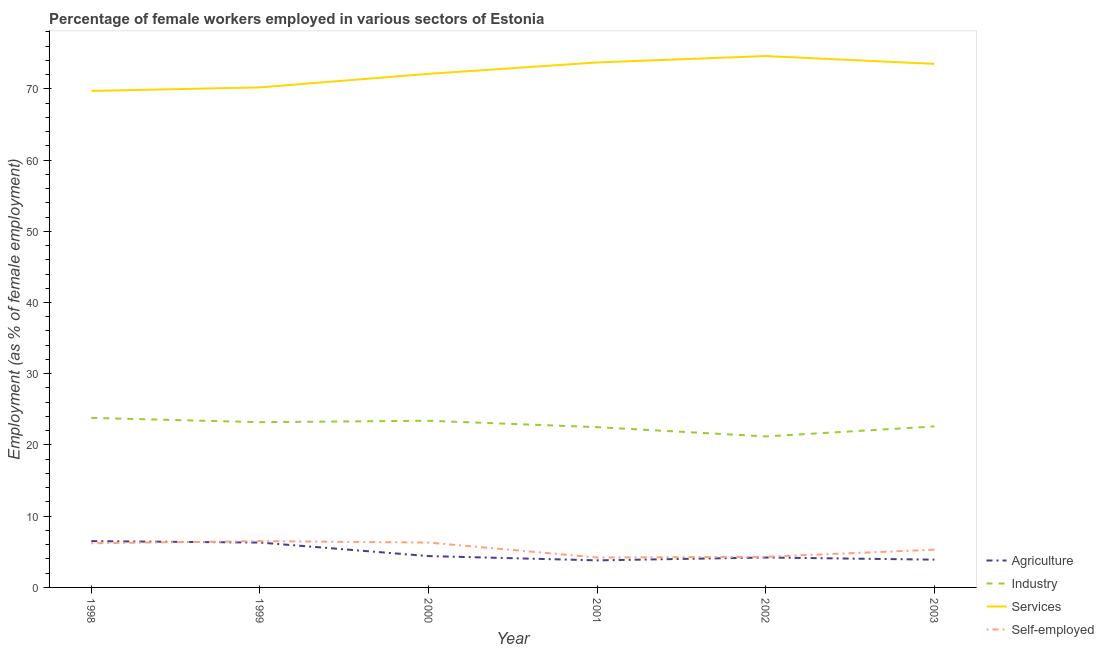What is the percentage of female workers in agriculture in 2003?
Your response must be concise. 3.9. Across all years, what is the maximum percentage of female workers in industry?
Offer a terse response. 23.8. Across all years, what is the minimum percentage of self employed female workers?
Give a very brief answer. 4.2. In which year was the percentage of female workers in industry minimum?
Provide a succinct answer. 2002. What is the total percentage of female workers in services in the graph?
Keep it short and to the point. 433.8. What is the difference between the percentage of female workers in services in 2000 and that in 2003?
Keep it short and to the point. -1.4. What is the difference between the percentage of female workers in industry in 2001 and the percentage of female workers in services in 1999?
Your answer should be compact. -47.7. What is the average percentage of self employed female workers per year?
Offer a terse response. 5.47. In the year 2003, what is the difference between the percentage of female workers in services and percentage of female workers in agriculture?
Make the answer very short. 69.6. What is the ratio of the percentage of female workers in industry in 1998 to that in 1999?
Your response must be concise. 1.03. Is the percentage of female workers in services in 1999 less than that in 2001?
Offer a terse response. Yes. Is the difference between the percentage of female workers in agriculture in 1998 and 2002 greater than the difference between the percentage of female workers in industry in 1998 and 2002?
Provide a succinct answer. No. What is the difference between the highest and the second highest percentage of female workers in services?
Give a very brief answer. 0.9. What is the difference between the highest and the lowest percentage of female workers in industry?
Your answer should be very brief. 2.6. In how many years, is the percentage of self employed female workers greater than the average percentage of self employed female workers taken over all years?
Give a very brief answer. 3. Is the sum of the percentage of female workers in industry in 2000 and 2003 greater than the maximum percentage of female workers in agriculture across all years?
Ensure brevity in your answer.  Yes. Is it the case that in every year, the sum of the percentage of self employed female workers and percentage of female workers in services is greater than the sum of percentage of female workers in industry and percentage of female workers in agriculture?
Provide a short and direct response. Yes. Is the percentage of female workers in industry strictly greater than the percentage of self employed female workers over the years?
Offer a very short reply. Yes. How many years are there in the graph?
Provide a succinct answer. 6. What is the difference between two consecutive major ticks on the Y-axis?
Your answer should be very brief. 10. Does the graph contain any zero values?
Offer a terse response. No. Does the graph contain grids?
Offer a terse response. No. Where does the legend appear in the graph?
Offer a terse response. Bottom right. What is the title of the graph?
Offer a very short reply. Percentage of female workers employed in various sectors of Estonia. What is the label or title of the Y-axis?
Your response must be concise. Employment (as % of female employment). What is the Employment (as % of female employment) in Industry in 1998?
Give a very brief answer. 23.8. What is the Employment (as % of female employment) of Services in 1998?
Provide a short and direct response. 69.7. What is the Employment (as % of female employment) in Self-employed in 1998?
Your answer should be compact. 6.2. What is the Employment (as % of female employment) of Agriculture in 1999?
Keep it short and to the point. 6.3. What is the Employment (as % of female employment) of Industry in 1999?
Give a very brief answer. 23.2. What is the Employment (as % of female employment) in Services in 1999?
Your answer should be very brief. 70.2. What is the Employment (as % of female employment) in Self-employed in 1999?
Keep it short and to the point. 6.5. What is the Employment (as % of female employment) of Agriculture in 2000?
Offer a very short reply. 4.4. What is the Employment (as % of female employment) in Industry in 2000?
Your response must be concise. 23.4. What is the Employment (as % of female employment) of Services in 2000?
Provide a succinct answer. 72.1. What is the Employment (as % of female employment) of Self-employed in 2000?
Keep it short and to the point. 6.3. What is the Employment (as % of female employment) in Agriculture in 2001?
Ensure brevity in your answer.  3.8. What is the Employment (as % of female employment) of Services in 2001?
Provide a short and direct response. 73.7. What is the Employment (as % of female employment) in Self-employed in 2001?
Provide a short and direct response. 4.2. What is the Employment (as % of female employment) in Agriculture in 2002?
Your answer should be compact. 4.2. What is the Employment (as % of female employment) in Industry in 2002?
Offer a very short reply. 21.2. What is the Employment (as % of female employment) in Services in 2002?
Give a very brief answer. 74.6. What is the Employment (as % of female employment) in Self-employed in 2002?
Your response must be concise. 4.3. What is the Employment (as % of female employment) of Agriculture in 2003?
Give a very brief answer. 3.9. What is the Employment (as % of female employment) in Industry in 2003?
Give a very brief answer. 22.6. What is the Employment (as % of female employment) of Services in 2003?
Provide a short and direct response. 73.5. What is the Employment (as % of female employment) in Self-employed in 2003?
Offer a very short reply. 5.3. Across all years, what is the maximum Employment (as % of female employment) of Agriculture?
Your response must be concise. 6.5. Across all years, what is the maximum Employment (as % of female employment) in Industry?
Your answer should be very brief. 23.8. Across all years, what is the maximum Employment (as % of female employment) in Services?
Ensure brevity in your answer.  74.6. Across all years, what is the minimum Employment (as % of female employment) of Agriculture?
Make the answer very short. 3.8. Across all years, what is the minimum Employment (as % of female employment) of Industry?
Provide a succinct answer. 21.2. Across all years, what is the minimum Employment (as % of female employment) of Services?
Your response must be concise. 69.7. Across all years, what is the minimum Employment (as % of female employment) in Self-employed?
Make the answer very short. 4.2. What is the total Employment (as % of female employment) in Agriculture in the graph?
Give a very brief answer. 29.1. What is the total Employment (as % of female employment) in Industry in the graph?
Offer a terse response. 136.7. What is the total Employment (as % of female employment) in Services in the graph?
Provide a succinct answer. 433.8. What is the total Employment (as % of female employment) of Self-employed in the graph?
Your answer should be compact. 32.8. What is the difference between the Employment (as % of female employment) of Agriculture in 1998 and that in 1999?
Make the answer very short. 0.2. What is the difference between the Employment (as % of female employment) in Industry in 1998 and that in 1999?
Your answer should be very brief. 0.6. What is the difference between the Employment (as % of female employment) of Services in 1998 and that in 1999?
Give a very brief answer. -0.5. What is the difference between the Employment (as % of female employment) in Industry in 1998 and that in 2000?
Offer a terse response. 0.4. What is the difference between the Employment (as % of female employment) of Self-employed in 1998 and that in 2000?
Provide a succinct answer. -0.1. What is the difference between the Employment (as % of female employment) of Agriculture in 1998 and that in 2002?
Offer a very short reply. 2.3. What is the difference between the Employment (as % of female employment) of Industry in 1998 and that in 2002?
Your answer should be compact. 2.6. What is the difference between the Employment (as % of female employment) of Self-employed in 1998 and that in 2002?
Ensure brevity in your answer.  1.9. What is the difference between the Employment (as % of female employment) in Industry in 1998 and that in 2003?
Offer a very short reply. 1.2. What is the difference between the Employment (as % of female employment) of Self-employed in 1998 and that in 2003?
Your answer should be compact. 0.9. What is the difference between the Employment (as % of female employment) of Agriculture in 1999 and that in 2001?
Offer a very short reply. 2.5. What is the difference between the Employment (as % of female employment) in Services in 1999 and that in 2001?
Offer a terse response. -3.5. What is the difference between the Employment (as % of female employment) of Agriculture in 1999 and that in 2002?
Offer a terse response. 2.1. What is the difference between the Employment (as % of female employment) in Services in 1999 and that in 2002?
Your answer should be very brief. -4.4. What is the difference between the Employment (as % of female employment) in Agriculture in 1999 and that in 2003?
Offer a terse response. 2.4. What is the difference between the Employment (as % of female employment) in Services in 1999 and that in 2003?
Keep it short and to the point. -3.3. What is the difference between the Employment (as % of female employment) of Self-employed in 1999 and that in 2003?
Give a very brief answer. 1.2. What is the difference between the Employment (as % of female employment) in Industry in 2000 and that in 2002?
Offer a terse response. 2.2. What is the difference between the Employment (as % of female employment) in Services in 2000 and that in 2002?
Your response must be concise. -2.5. What is the difference between the Employment (as % of female employment) of Agriculture in 2000 and that in 2003?
Your answer should be compact. 0.5. What is the difference between the Employment (as % of female employment) of Industry in 2000 and that in 2003?
Ensure brevity in your answer.  0.8. What is the difference between the Employment (as % of female employment) in Services in 2000 and that in 2003?
Offer a very short reply. -1.4. What is the difference between the Employment (as % of female employment) in Self-employed in 2000 and that in 2003?
Your answer should be very brief. 1. What is the difference between the Employment (as % of female employment) in Self-employed in 2001 and that in 2002?
Provide a short and direct response. -0.1. What is the difference between the Employment (as % of female employment) of Agriculture in 2001 and that in 2003?
Your answer should be compact. -0.1. What is the difference between the Employment (as % of female employment) in Services in 2001 and that in 2003?
Give a very brief answer. 0.2. What is the difference between the Employment (as % of female employment) in Self-employed in 2001 and that in 2003?
Offer a terse response. -1.1. What is the difference between the Employment (as % of female employment) of Agriculture in 2002 and that in 2003?
Give a very brief answer. 0.3. What is the difference between the Employment (as % of female employment) of Industry in 2002 and that in 2003?
Offer a very short reply. -1.4. What is the difference between the Employment (as % of female employment) in Services in 2002 and that in 2003?
Keep it short and to the point. 1.1. What is the difference between the Employment (as % of female employment) of Self-employed in 2002 and that in 2003?
Give a very brief answer. -1. What is the difference between the Employment (as % of female employment) in Agriculture in 1998 and the Employment (as % of female employment) in Industry in 1999?
Keep it short and to the point. -16.7. What is the difference between the Employment (as % of female employment) in Agriculture in 1998 and the Employment (as % of female employment) in Services in 1999?
Your answer should be compact. -63.7. What is the difference between the Employment (as % of female employment) of Industry in 1998 and the Employment (as % of female employment) of Services in 1999?
Offer a terse response. -46.4. What is the difference between the Employment (as % of female employment) of Industry in 1998 and the Employment (as % of female employment) of Self-employed in 1999?
Provide a short and direct response. 17.3. What is the difference between the Employment (as % of female employment) of Services in 1998 and the Employment (as % of female employment) of Self-employed in 1999?
Keep it short and to the point. 63.2. What is the difference between the Employment (as % of female employment) of Agriculture in 1998 and the Employment (as % of female employment) of Industry in 2000?
Provide a succinct answer. -16.9. What is the difference between the Employment (as % of female employment) in Agriculture in 1998 and the Employment (as % of female employment) in Services in 2000?
Ensure brevity in your answer.  -65.6. What is the difference between the Employment (as % of female employment) of Agriculture in 1998 and the Employment (as % of female employment) of Self-employed in 2000?
Your response must be concise. 0.2. What is the difference between the Employment (as % of female employment) in Industry in 1998 and the Employment (as % of female employment) in Services in 2000?
Keep it short and to the point. -48.3. What is the difference between the Employment (as % of female employment) of Industry in 1998 and the Employment (as % of female employment) of Self-employed in 2000?
Give a very brief answer. 17.5. What is the difference between the Employment (as % of female employment) of Services in 1998 and the Employment (as % of female employment) of Self-employed in 2000?
Provide a short and direct response. 63.4. What is the difference between the Employment (as % of female employment) in Agriculture in 1998 and the Employment (as % of female employment) in Industry in 2001?
Make the answer very short. -16. What is the difference between the Employment (as % of female employment) in Agriculture in 1998 and the Employment (as % of female employment) in Services in 2001?
Provide a short and direct response. -67.2. What is the difference between the Employment (as % of female employment) in Industry in 1998 and the Employment (as % of female employment) in Services in 2001?
Offer a very short reply. -49.9. What is the difference between the Employment (as % of female employment) of Industry in 1998 and the Employment (as % of female employment) of Self-employed in 2001?
Offer a very short reply. 19.6. What is the difference between the Employment (as % of female employment) of Services in 1998 and the Employment (as % of female employment) of Self-employed in 2001?
Make the answer very short. 65.5. What is the difference between the Employment (as % of female employment) of Agriculture in 1998 and the Employment (as % of female employment) of Industry in 2002?
Offer a terse response. -14.7. What is the difference between the Employment (as % of female employment) of Agriculture in 1998 and the Employment (as % of female employment) of Services in 2002?
Provide a succinct answer. -68.1. What is the difference between the Employment (as % of female employment) in Agriculture in 1998 and the Employment (as % of female employment) in Self-employed in 2002?
Your answer should be compact. 2.2. What is the difference between the Employment (as % of female employment) of Industry in 1998 and the Employment (as % of female employment) of Services in 2002?
Offer a very short reply. -50.8. What is the difference between the Employment (as % of female employment) in Services in 1998 and the Employment (as % of female employment) in Self-employed in 2002?
Ensure brevity in your answer.  65.4. What is the difference between the Employment (as % of female employment) in Agriculture in 1998 and the Employment (as % of female employment) in Industry in 2003?
Your answer should be very brief. -16.1. What is the difference between the Employment (as % of female employment) of Agriculture in 1998 and the Employment (as % of female employment) of Services in 2003?
Give a very brief answer. -67. What is the difference between the Employment (as % of female employment) in Industry in 1998 and the Employment (as % of female employment) in Services in 2003?
Your answer should be very brief. -49.7. What is the difference between the Employment (as % of female employment) in Services in 1998 and the Employment (as % of female employment) in Self-employed in 2003?
Make the answer very short. 64.4. What is the difference between the Employment (as % of female employment) of Agriculture in 1999 and the Employment (as % of female employment) of Industry in 2000?
Give a very brief answer. -17.1. What is the difference between the Employment (as % of female employment) in Agriculture in 1999 and the Employment (as % of female employment) in Services in 2000?
Keep it short and to the point. -65.8. What is the difference between the Employment (as % of female employment) of Industry in 1999 and the Employment (as % of female employment) of Services in 2000?
Ensure brevity in your answer.  -48.9. What is the difference between the Employment (as % of female employment) in Industry in 1999 and the Employment (as % of female employment) in Self-employed in 2000?
Offer a terse response. 16.9. What is the difference between the Employment (as % of female employment) of Services in 1999 and the Employment (as % of female employment) of Self-employed in 2000?
Ensure brevity in your answer.  63.9. What is the difference between the Employment (as % of female employment) in Agriculture in 1999 and the Employment (as % of female employment) in Industry in 2001?
Your response must be concise. -16.2. What is the difference between the Employment (as % of female employment) of Agriculture in 1999 and the Employment (as % of female employment) of Services in 2001?
Your answer should be compact. -67.4. What is the difference between the Employment (as % of female employment) in Agriculture in 1999 and the Employment (as % of female employment) in Self-employed in 2001?
Your answer should be very brief. 2.1. What is the difference between the Employment (as % of female employment) in Industry in 1999 and the Employment (as % of female employment) in Services in 2001?
Your answer should be very brief. -50.5. What is the difference between the Employment (as % of female employment) of Industry in 1999 and the Employment (as % of female employment) of Self-employed in 2001?
Your response must be concise. 19. What is the difference between the Employment (as % of female employment) in Agriculture in 1999 and the Employment (as % of female employment) in Industry in 2002?
Offer a very short reply. -14.9. What is the difference between the Employment (as % of female employment) of Agriculture in 1999 and the Employment (as % of female employment) of Services in 2002?
Your response must be concise. -68.3. What is the difference between the Employment (as % of female employment) of Industry in 1999 and the Employment (as % of female employment) of Services in 2002?
Your answer should be compact. -51.4. What is the difference between the Employment (as % of female employment) of Industry in 1999 and the Employment (as % of female employment) of Self-employed in 2002?
Offer a very short reply. 18.9. What is the difference between the Employment (as % of female employment) in Services in 1999 and the Employment (as % of female employment) in Self-employed in 2002?
Provide a short and direct response. 65.9. What is the difference between the Employment (as % of female employment) of Agriculture in 1999 and the Employment (as % of female employment) of Industry in 2003?
Give a very brief answer. -16.3. What is the difference between the Employment (as % of female employment) of Agriculture in 1999 and the Employment (as % of female employment) of Services in 2003?
Keep it short and to the point. -67.2. What is the difference between the Employment (as % of female employment) in Agriculture in 1999 and the Employment (as % of female employment) in Self-employed in 2003?
Your response must be concise. 1. What is the difference between the Employment (as % of female employment) in Industry in 1999 and the Employment (as % of female employment) in Services in 2003?
Offer a terse response. -50.3. What is the difference between the Employment (as % of female employment) of Services in 1999 and the Employment (as % of female employment) of Self-employed in 2003?
Provide a short and direct response. 64.9. What is the difference between the Employment (as % of female employment) of Agriculture in 2000 and the Employment (as % of female employment) of Industry in 2001?
Provide a succinct answer. -18.1. What is the difference between the Employment (as % of female employment) in Agriculture in 2000 and the Employment (as % of female employment) in Services in 2001?
Provide a succinct answer. -69.3. What is the difference between the Employment (as % of female employment) in Industry in 2000 and the Employment (as % of female employment) in Services in 2001?
Provide a short and direct response. -50.3. What is the difference between the Employment (as % of female employment) of Services in 2000 and the Employment (as % of female employment) of Self-employed in 2001?
Keep it short and to the point. 67.9. What is the difference between the Employment (as % of female employment) in Agriculture in 2000 and the Employment (as % of female employment) in Industry in 2002?
Your answer should be compact. -16.8. What is the difference between the Employment (as % of female employment) in Agriculture in 2000 and the Employment (as % of female employment) in Services in 2002?
Make the answer very short. -70.2. What is the difference between the Employment (as % of female employment) in Industry in 2000 and the Employment (as % of female employment) in Services in 2002?
Keep it short and to the point. -51.2. What is the difference between the Employment (as % of female employment) of Industry in 2000 and the Employment (as % of female employment) of Self-employed in 2002?
Provide a short and direct response. 19.1. What is the difference between the Employment (as % of female employment) in Services in 2000 and the Employment (as % of female employment) in Self-employed in 2002?
Keep it short and to the point. 67.8. What is the difference between the Employment (as % of female employment) in Agriculture in 2000 and the Employment (as % of female employment) in Industry in 2003?
Offer a terse response. -18.2. What is the difference between the Employment (as % of female employment) of Agriculture in 2000 and the Employment (as % of female employment) of Services in 2003?
Offer a terse response. -69.1. What is the difference between the Employment (as % of female employment) of Agriculture in 2000 and the Employment (as % of female employment) of Self-employed in 2003?
Make the answer very short. -0.9. What is the difference between the Employment (as % of female employment) in Industry in 2000 and the Employment (as % of female employment) in Services in 2003?
Your response must be concise. -50.1. What is the difference between the Employment (as % of female employment) in Services in 2000 and the Employment (as % of female employment) in Self-employed in 2003?
Provide a short and direct response. 66.8. What is the difference between the Employment (as % of female employment) of Agriculture in 2001 and the Employment (as % of female employment) of Industry in 2002?
Your response must be concise. -17.4. What is the difference between the Employment (as % of female employment) of Agriculture in 2001 and the Employment (as % of female employment) of Services in 2002?
Provide a succinct answer. -70.8. What is the difference between the Employment (as % of female employment) of Industry in 2001 and the Employment (as % of female employment) of Services in 2002?
Ensure brevity in your answer.  -52.1. What is the difference between the Employment (as % of female employment) of Services in 2001 and the Employment (as % of female employment) of Self-employed in 2002?
Provide a succinct answer. 69.4. What is the difference between the Employment (as % of female employment) in Agriculture in 2001 and the Employment (as % of female employment) in Industry in 2003?
Make the answer very short. -18.8. What is the difference between the Employment (as % of female employment) of Agriculture in 2001 and the Employment (as % of female employment) of Services in 2003?
Your answer should be very brief. -69.7. What is the difference between the Employment (as % of female employment) of Industry in 2001 and the Employment (as % of female employment) of Services in 2003?
Provide a short and direct response. -51. What is the difference between the Employment (as % of female employment) in Services in 2001 and the Employment (as % of female employment) in Self-employed in 2003?
Ensure brevity in your answer.  68.4. What is the difference between the Employment (as % of female employment) of Agriculture in 2002 and the Employment (as % of female employment) of Industry in 2003?
Keep it short and to the point. -18.4. What is the difference between the Employment (as % of female employment) in Agriculture in 2002 and the Employment (as % of female employment) in Services in 2003?
Your answer should be compact. -69.3. What is the difference between the Employment (as % of female employment) in Industry in 2002 and the Employment (as % of female employment) in Services in 2003?
Your answer should be very brief. -52.3. What is the difference between the Employment (as % of female employment) in Industry in 2002 and the Employment (as % of female employment) in Self-employed in 2003?
Your answer should be compact. 15.9. What is the difference between the Employment (as % of female employment) in Services in 2002 and the Employment (as % of female employment) in Self-employed in 2003?
Your response must be concise. 69.3. What is the average Employment (as % of female employment) in Agriculture per year?
Your response must be concise. 4.85. What is the average Employment (as % of female employment) in Industry per year?
Your response must be concise. 22.78. What is the average Employment (as % of female employment) in Services per year?
Ensure brevity in your answer.  72.3. What is the average Employment (as % of female employment) in Self-employed per year?
Provide a short and direct response. 5.47. In the year 1998, what is the difference between the Employment (as % of female employment) in Agriculture and Employment (as % of female employment) in Industry?
Provide a short and direct response. -17.3. In the year 1998, what is the difference between the Employment (as % of female employment) of Agriculture and Employment (as % of female employment) of Services?
Offer a very short reply. -63.2. In the year 1998, what is the difference between the Employment (as % of female employment) in Industry and Employment (as % of female employment) in Services?
Give a very brief answer. -45.9. In the year 1998, what is the difference between the Employment (as % of female employment) in Industry and Employment (as % of female employment) in Self-employed?
Give a very brief answer. 17.6. In the year 1998, what is the difference between the Employment (as % of female employment) of Services and Employment (as % of female employment) of Self-employed?
Offer a very short reply. 63.5. In the year 1999, what is the difference between the Employment (as % of female employment) in Agriculture and Employment (as % of female employment) in Industry?
Ensure brevity in your answer.  -16.9. In the year 1999, what is the difference between the Employment (as % of female employment) of Agriculture and Employment (as % of female employment) of Services?
Keep it short and to the point. -63.9. In the year 1999, what is the difference between the Employment (as % of female employment) in Industry and Employment (as % of female employment) in Services?
Your answer should be very brief. -47. In the year 1999, what is the difference between the Employment (as % of female employment) in Services and Employment (as % of female employment) in Self-employed?
Make the answer very short. 63.7. In the year 2000, what is the difference between the Employment (as % of female employment) in Agriculture and Employment (as % of female employment) in Services?
Your response must be concise. -67.7. In the year 2000, what is the difference between the Employment (as % of female employment) of Agriculture and Employment (as % of female employment) of Self-employed?
Your answer should be very brief. -1.9. In the year 2000, what is the difference between the Employment (as % of female employment) in Industry and Employment (as % of female employment) in Services?
Keep it short and to the point. -48.7. In the year 2000, what is the difference between the Employment (as % of female employment) in Industry and Employment (as % of female employment) in Self-employed?
Your answer should be compact. 17.1. In the year 2000, what is the difference between the Employment (as % of female employment) of Services and Employment (as % of female employment) of Self-employed?
Your response must be concise. 65.8. In the year 2001, what is the difference between the Employment (as % of female employment) in Agriculture and Employment (as % of female employment) in Industry?
Provide a succinct answer. -18.7. In the year 2001, what is the difference between the Employment (as % of female employment) in Agriculture and Employment (as % of female employment) in Services?
Give a very brief answer. -69.9. In the year 2001, what is the difference between the Employment (as % of female employment) of Industry and Employment (as % of female employment) of Services?
Make the answer very short. -51.2. In the year 2001, what is the difference between the Employment (as % of female employment) of Industry and Employment (as % of female employment) of Self-employed?
Keep it short and to the point. 18.3. In the year 2001, what is the difference between the Employment (as % of female employment) of Services and Employment (as % of female employment) of Self-employed?
Give a very brief answer. 69.5. In the year 2002, what is the difference between the Employment (as % of female employment) in Agriculture and Employment (as % of female employment) in Services?
Provide a short and direct response. -70.4. In the year 2002, what is the difference between the Employment (as % of female employment) in Industry and Employment (as % of female employment) in Services?
Offer a very short reply. -53.4. In the year 2002, what is the difference between the Employment (as % of female employment) in Industry and Employment (as % of female employment) in Self-employed?
Keep it short and to the point. 16.9. In the year 2002, what is the difference between the Employment (as % of female employment) of Services and Employment (as % of female employment) of Self-employed?
Your answer should be compact. 70.3. In the year 2003, what is the difference between the Employment (as % of female employment) of Agriculture and Employment (as % of female employment) of Industry?
Offer a terse response. -18.7. In the year 2003, what is the difference between the Employment (as % of female employment) in Agriculture and Employment (as % of female employment) in Services?
Provide a short and direct response. -69.6. In the year 2003, what is the difference between the Employment (as % of female employment) in Agriculture and Employment (as % of female employment) in Self-employed?
Provide a succinct answer. -1.4. In the year 2003, what is the difference between the Employment (as % of female employment) of Industry and Employment (as % of female employment) of Services?
Keep it short and to the point. -50.9. In the year 2003, what is the difference between the Employment (as % of female employment) in Industry and Employment (as % of female employment) in Self-employed?
Provide a succinct answer. 17.3. In the year 2003, what is the difference between the Employment (as % of female employment) of Services and Employment (as % of female employment) of Self-employed?
Offer a terse response. 68.2. What is the ratio of the Employment (as % of female employment) in Agriculture in 1998 to that in 1999?
Ensure brevity in your answer.  1.03. What is the ratio of the Employment (as % of female employment) of Industry in 1998 to that in 1999?
Give a very brief answer. 1.03. What is the ratio of the Employment (as % of female employment) of Self-employed in 1998 to that in 1999?
Your answer should be compact. 0.95. What is the ratio of the Employment (as % of female employment) in Agriculture in 1998 to that in 2000?
Ensure brevity in your answer.  1.48. What is the ratio of the Employment (as % of female employment) of Industry in 1998 to that in 2000?
Offer a very short reply. 1.02. What is the ratio of the Employment (as % of female employment) in Services in 1998 to that in 2000?
Your answer should be very brief. 0.97. What is the ratio of the Employment (as % of female employment) of Self-employed in 1998 to that in 2000?
Provide a short and direct response. 0.98. What is the ratio of the Employment (as % of female employment) in Agriculture in 1998 to that in 2001?
Offer a very short reply. 1.71. What is the ratio of the Employment (as % of female employment) of Industry in 1998 to that in 2001?
Your response must be concise. 1.06. What is the ratio of the Employment (as % of female employment) of Services in 1998 to that in 2001?
Provide a short and direct response. 0.95. What is the ratio of the Employment (as % of female employment) in Self-employed in 1998 to that in 2001?
Make the answer very short. 1.48. What is the ratio of the Employment (as % of female employment) in Agriculture in 1998 to that in 2002?
Offer a very short reply. 1.55. What is the ratio of the Employment (as % of female employment) in Industry in 1998 to that in 2002?
Provide a short and direct response. 1.12. What is the ratio of the Employment (as % of female employment) in Services in 1998 to that in 2002?
Provide a succinct answer. 0.93. What is the ratio of the Employment (as % of female employment) of Self-employed in 1998 to that in 2002?
Offer a terse response. 1.44. What is the ratio of the Employment (as % of female employment) in Industry in 1998 to that in 2003?
Provide a succinct answer. 1.05. What is the ratio of the Employment (as % of female employment) of Services in 1998 to that in 2003?
Offer a terse response. 0.95. What is the ratio of the Employment (as % of female employment) in Self-employed in 1998 to that in 2003?
Offer a terse response. 1.17. What is the ratio of the Employment (as % of female employment) of Agriculture in 1999 to that in 2000?
Make the answer very short. 1.43. What is the ratio of the Employment (as % of female employment) of Services in 1999 to that in 2000?
Keep it short and to the point. 0.97. What is the ratio of the Employment (as % of female employment) in Self-employed in 1999 to that in 2000?
Provide a short and direct response. 1.03. What is the ratio of the Employment (as % of female employment) in Agriculture in 1999 to that in 2001?
Provide a succinct answer. 1.66. What is the ratio of the Employment (as % of female employment) of Industry in 1999 to that in 2001?
Ensure brevity in your answer.  1.03. What is the ratio of the Employment (as % of female employment) in Services in 1999 to that in 2001?
Provide a succinct answer. 0.95. What is the ratio of the Employment (as % of female employment) in Self-employed in 1999 to that in 2001?
Give a very brief answer. 1.55. What is the ratio of the Employment (as % of female employment) of Industry in 1999 to that in 2002?
Offer a terse response. 1.09. What is the ratio of the Employment (as % of female employment) in Services in 1999 to that in 2002?
Your response must be concise. 0.94. What is the ratio of the Employment (as % of female employment) of Self-employed in 1999 to that in 2002?
Keep it short and to the point. 1.51. What is the ratio of the Employment (as % of female employment) in Agriculture in 1999 to that in 2003?
Your answer should be very brief. 1.62. What is the ratio of the Employment (as % of female employment) of Industry in 1999 to that in 2003?
Your answer should be very brief. 1.03. What is the ratio of the Employment (as % of female employment) in Services in 1999 to that in 2003?
Your answer should be very brief. 0.96. What is the ratio of the Employment (as % of female employment) in Self-employed in 1999 to that in 2003?
Ensure brevity in your answer.  1.23. What is the ratio of the Employment (as % of female employment) in Agriculture in 2000 to that in 2001?
Keep it short and to the point. 1.16. What is the ratio of the Employment (as % of female employment) in Industry in 2000 to that in 2001?
Keep it short and to the point. 1.04. What is the ratio of the Employment (as % of female employment) of Services in 2000 to that in 2001?
Offer a very short reply. 0.98. What is the ratio of the Employment (as % of female employment) in Self-employed in 2000 to that in 2001?
Provide a succinct answer. 1.5. What is the ratio of the Employment (as % of female employment) in Agriculture in 2000 to that in 2002?
Make the answer very short. 1.05. What is the ratio of the Employment (as % of female employment) in Industry in 2000 to that in 2002?
Your answer should be compact. 1.1. What is the ratio of the Employment (as % of female employment) in Services in 2000 to that in 2002?
Make the answer very short. 0.97. What is the ratio of the Employment (as % of female employment) of Self-employed in 2000 to that in 2002?
Ensure brevity in your answer.  1.47. What is the ratio of the Employment (as % of female employment) of Agriculture in 2000 to that in 2003?
Provide a short and direct response. 1.13. What is the ratio of the Employment (as % of female employment) of Industry in 2000 to that in 2003?
Your answer should be compact. 1.04. What is the ratio of the Employment (as % of female employment) in Self-employed in 2000 to that in 2003?
Keep it short and to the point. 1.19. What is the ratio of the Employment (as % of female employment) in Agriculture in 2001 to that in 2002?
Ensure brevity in your answer.  0.9. What is the ratio of the Employment (as % of female employment) in Industry in 2001 to that in 2002?
Provide a succinct answer. 1.06. What is the ratio of the Employment (as % of female employment) of Services in 2001 to that in 2002?
Offer a very short reply. 0.99. What is the ratio of the Employment (as % of female employment) of Self-employed in 2001 to that in 2002?
Make the answer very short. 0.98. What is the ratio of the Employment (as % of female employment) of Agriculture in 2001 to that in 2003?
Provide a short and direct response. 0.97. What is the ratio of the Employment (as % of female employment) of Self-employed in 2001 to that in 2003?
Your answer should be very brief. 0.79. What is the ratio of the Employment (as % of female employment) of Agriculture in 2002 to that in 2003?
Provide a succinct answer. 1.08. What is the ratio of the Employment (as % of female employment) in Industry in 2002 to that in 2003?
Ensure brevity in your answer.  0.94. What is the ratio of the Employment (as % of female employment) of Self-employed in 2002 to that in 2003?
Offer a terse response. 0.81. What is the difference between the highest and the second highest Employment (as % of female employment) in Industry?
Give a very brief answer. 0.4. What is the difference between the highest and the second highest Employment (as % of female employment) of Self-employed?
Provide a succinct answer. 0.2. What is the difference between the highest and the lowest Employment (as % of female employment) in Agriculture?
Provide a succinct answer. 2.7. What is the difference between the highest and the lowest Employment (as % of female employment) in Industry?
Make the answer very short. 2.6. What is the difference between the highest and the lowest Employment (as % of female employment) of Services?
Your answer should be compact. 4.9. 